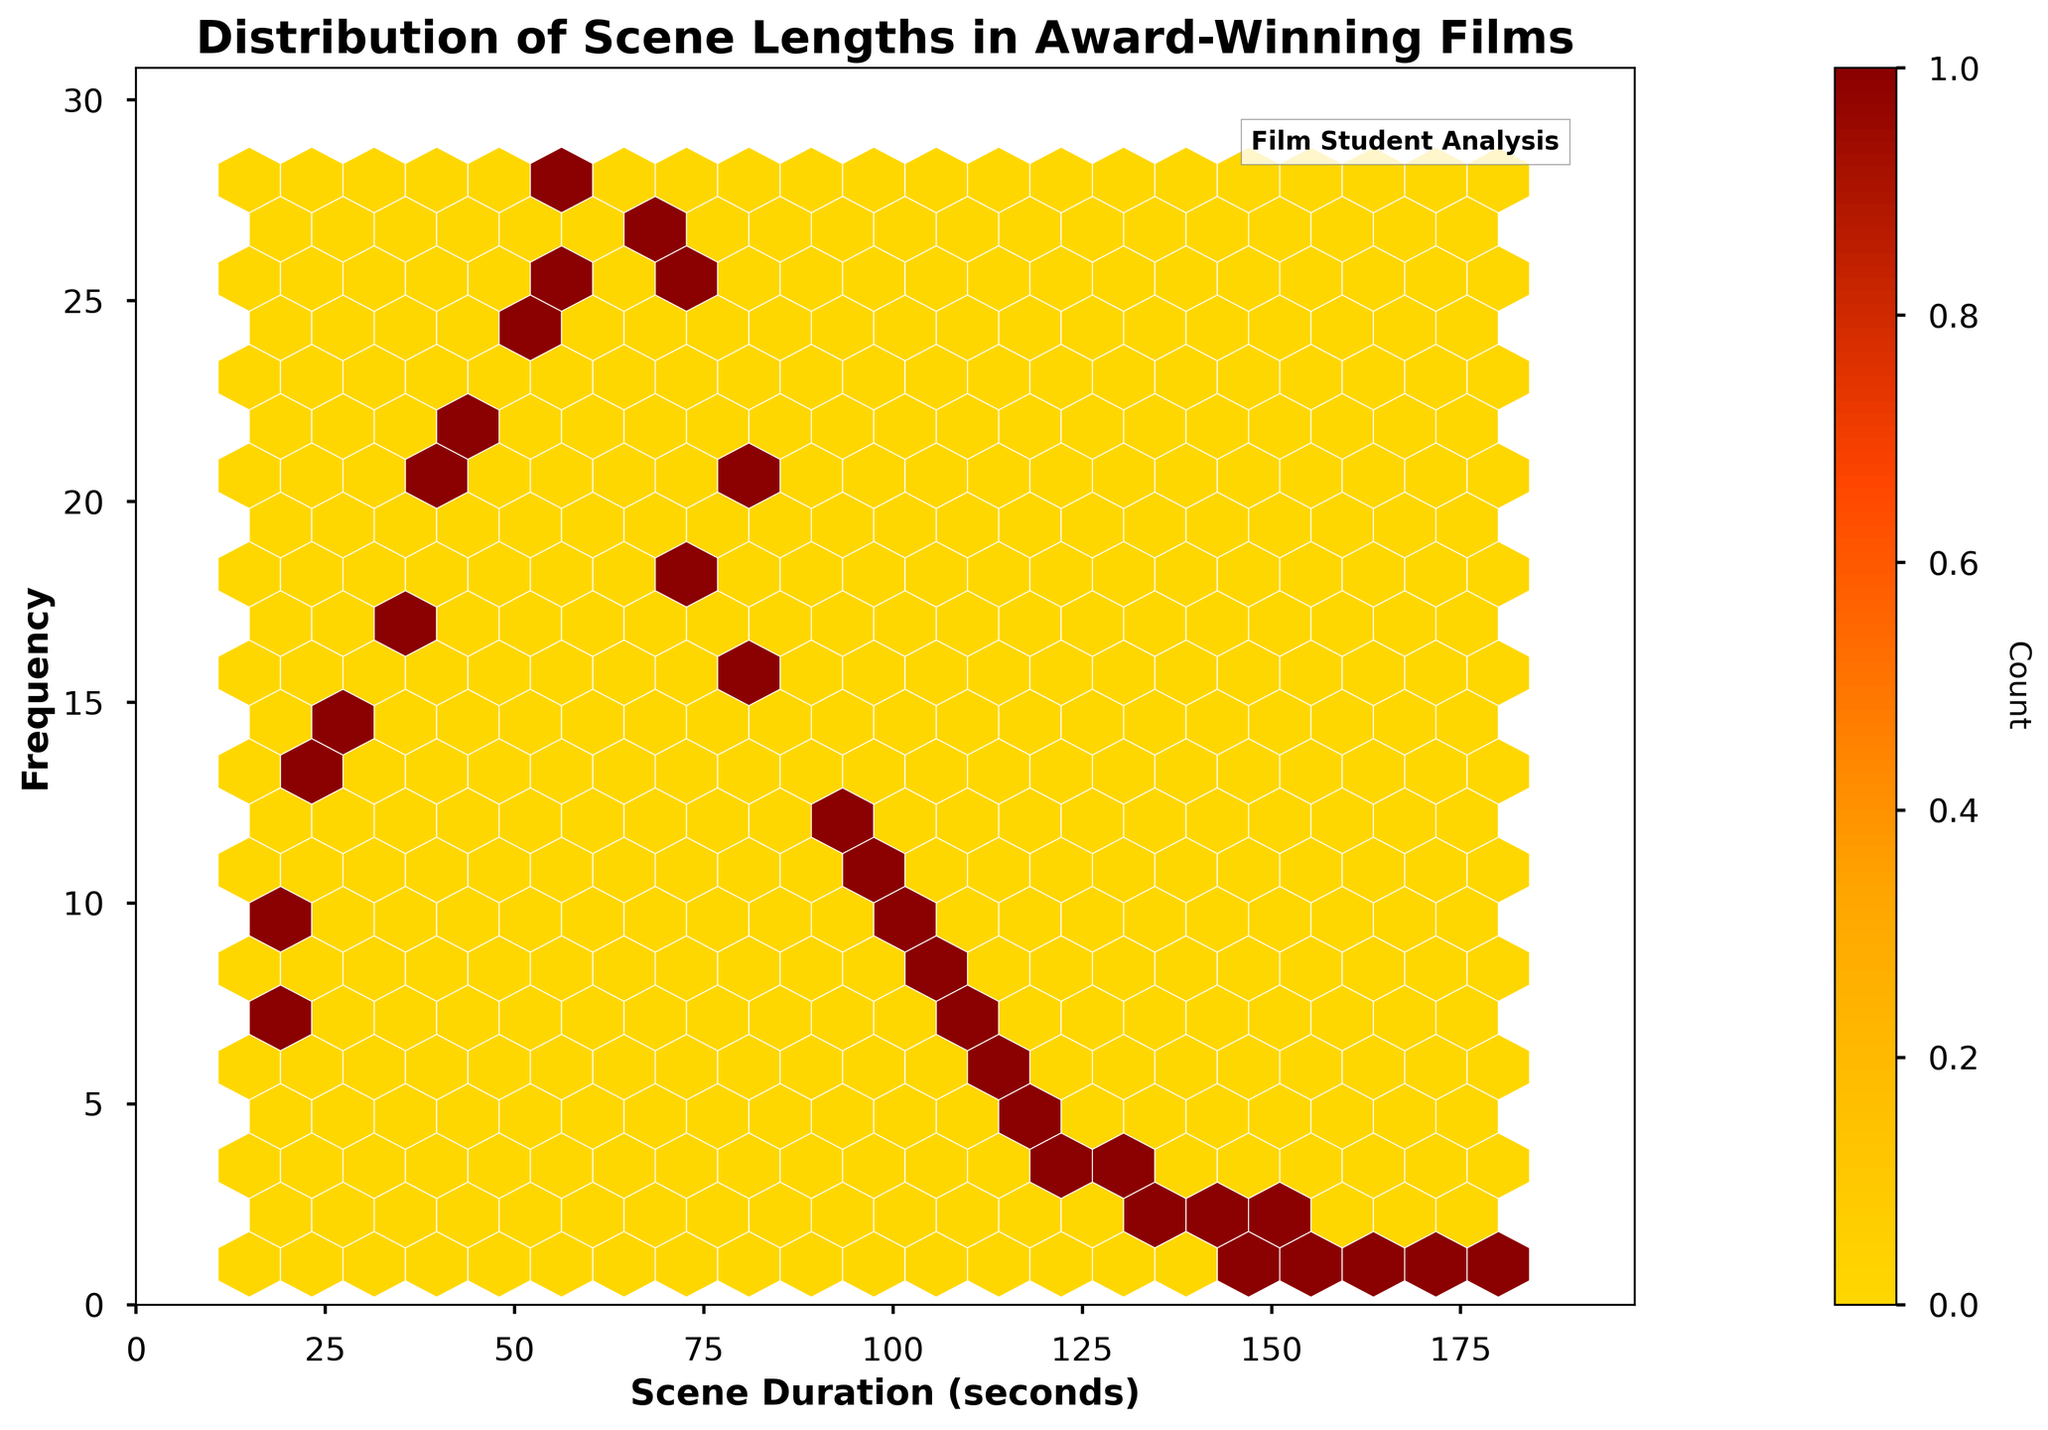What's the title of the plot? The title of the plot is typically found at the top of the figure. It provides an overview of what the plot represents. In this case, it is specified as 'Distribution of Scene Lengths in Award-Winning Films'.
Answer: Distribution of Scene Lengths in Award-Winning Films What do the x and y axes represent? The x-axis label is 'Scene Duration (seconds)', which indicates the length of the scenes in seconds. The y-axis label is 'Frequency', which shows how often each scene duration occurs in the films.
Answer: x-axis: Scene Duration (seconds), y-axis: Frequency What is the color range used in the hexbin plot? The color range in a hexbin plot represents the frequency of the data points within each hexagonal bin. Starting from light yellow at the lowest frequency, it transitions through orange and red to dark red at the highest frequency.
Answer: Yellow to dark red What is the general trend of scene durations in award-winning films? Observing the hexbin plot's color concentration, most scene durations cluster around shorter durations, especially between 25 to 80 seconds, showing higher frequencies. As scene durations increase beyond this range, frequencies decrease.
Answer: Higher frequency of shorter scene durations Which scene duration has the highest frequency? To determine this, find the bin with the darkest color, reflecting the highest frequency. The data shows this peak around a duration of 60 seconds, indicated by deeper red hues within the plot.
Answer: 60 seconds How does the frequency of 30-second scenes compare to 105-second scenes? Look at the color depth at these durations. The 30-second scenes are light yellow, indicating a moderate frequency (15 occurrences), while 105-second scenes have a much lighter or near absence of color, indicating significantly fewer occurrences (8).
Answer: 30-second scenes are more frequent What can be inferred about the frequency of scenes longer than 120 seconds? Notice that beyond 120 seconds, the hexbin plot shows very light colors or almost invisible bins, indicating very low frequencies. The plotted values decrease significantly for these durations.
Answer: Very low frequency Compare the scene lengths of 45 seconds and 80 seconds in terms of frequency. On the hexbin plot, 45-second scene bins are darker, indicating a higher frequency compared to 80-second scenes, which have lighter color bins. The values are 22 for 45 seconds and 20 for 80 seconds.
Answer: 45-second scenes are more frequent What does the color bar represent and how is it used? The color bar to the side of the hexbin plot shows the frequency count that different colors correspond to, ranging from low (yellow) to high (dark red). It helps in quantitatively interpreting the colors in the hexagonal bins.
Answer: Frequency count What does the value 1 at frequency suggest about the scene duration 165 seconds? If you look at the hexbin plot, the hexagon representing 165-second scene duration is only lightly colored, signifying a very low frequency of occurrence, which is exactly 1. This shows it is a rare duration in comparison to shorter scenes.
Answer: Very low, rare duration 